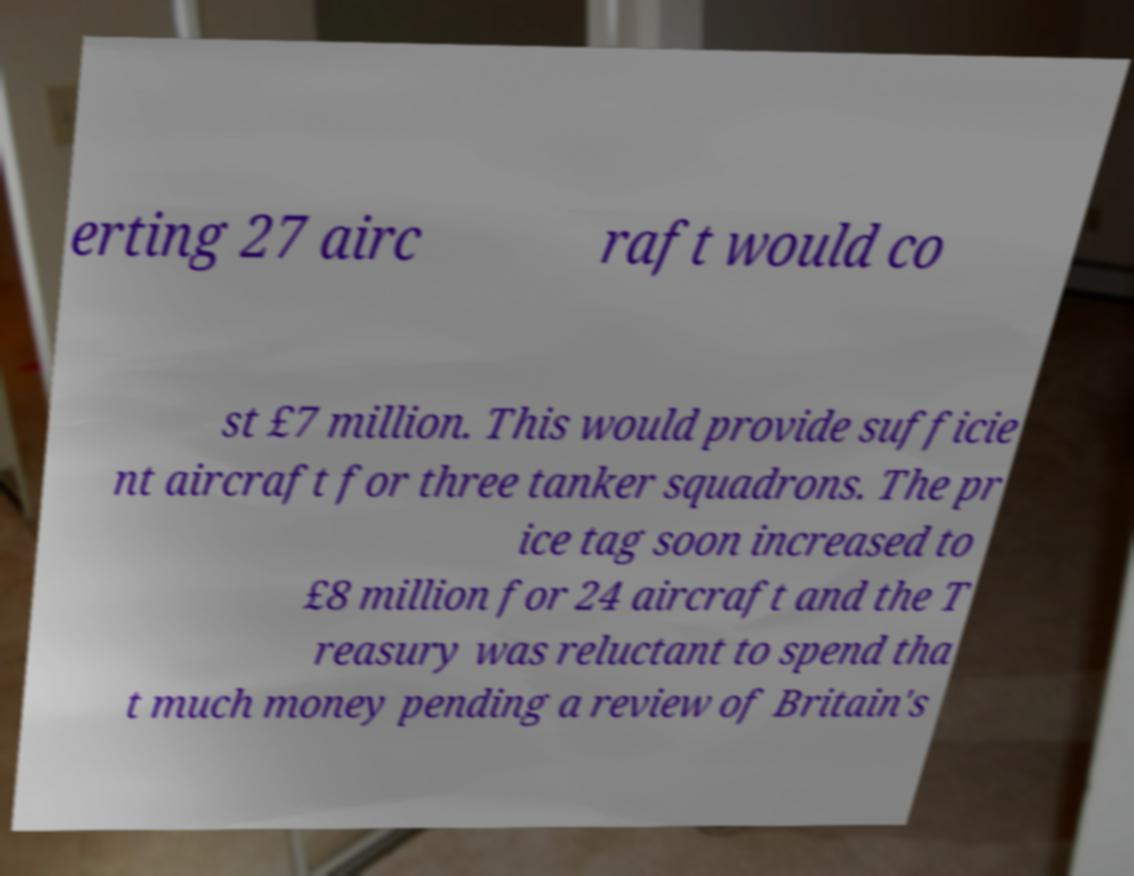Can you accurately transcribe the text from the provided image for me? erting 27 airc raft would co st £7 million. This would provide sufficie nt aircraft for three tanker squadrons. The pr ice tag soon increased to £8 million for 24 aircraft and the T reasury was reluctant to spend tha t much money pending a review of Britain's 